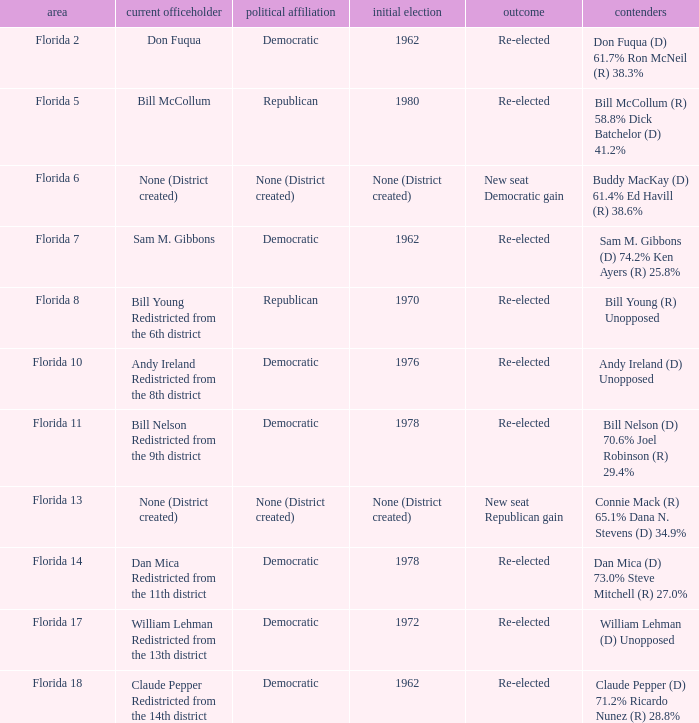What's the first elected with district being florida 7 1962.0. 